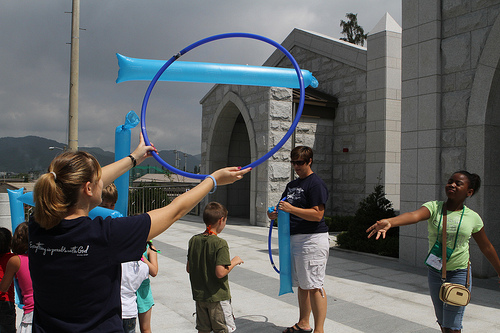<image>
Is the boy behind the woman? Yes. From this viewpoint, the boy is positioned behind the woman, with the woman partially or fully occluding the boy. Is the tree behind the building? Yes. From this viewpoint, the tree is positioned behind the building, with the building partially or fully occluding the tree. 